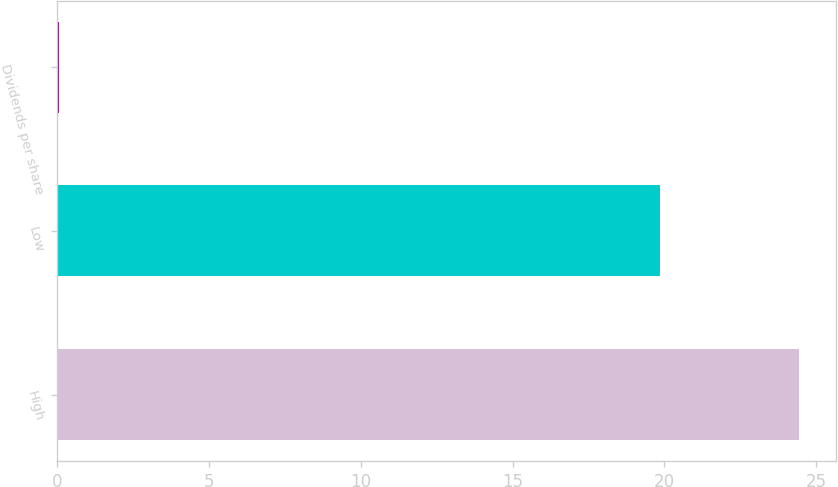Convert chart to OTSL. <chart><loc_0><loc_0><loc_500><loc_500><bar_chart><fcel>High<fcel>Low<fcel>Dividends per share<nl><fcel>24.45<fcel>19.85<fcel>0.06<nl></chart> 